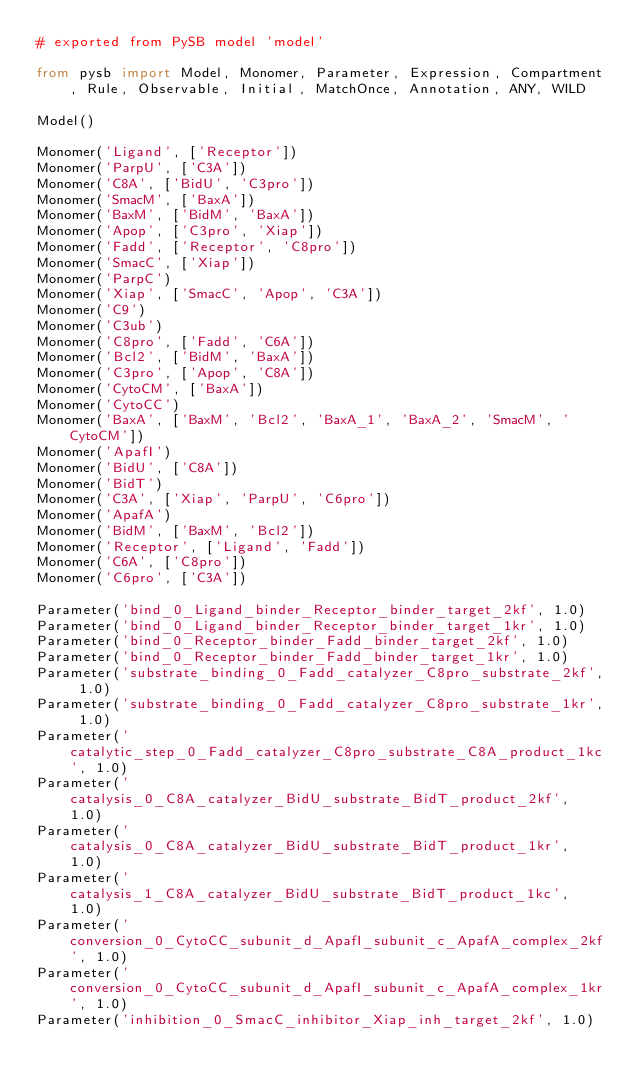<code> <loc_0><loc_0><loc_500><loc_500><_Python_># exported from PySB model 'model'

from pysb import Model, Monomer, Parameter, Expression, Compartment, Rule, Observable, Initial, MatchOnce, Annotation, ANY, WILD

Model()

Monomer('Ligand', ['Receptor'])
Monomer('ParpU', ['C3A'])
Monomer('C8A', ['BidU', 'C3pro'])
Monomer('SmacM', ['BaxA'])
Monomer('BaxM', ['BidM', 'BaxA'])
Monomer('Apop', ['C3pro', 'Xiap'])
Monomer('Fadd', ['Receptor', 'C8pro'])
Monomer('SmacC', ['Xiap'])
Monomer('ParpC')
Monomer('Xiap', ['SmacC', 'Apop', 'C3A'])
Monomer('C9')
Monomer('C3ub')
Monomer('C8pro', ['Fadd', 'C6A'])
Monomer('Bcl2', ['BidM', 'BaxA'])
Monomer('C3pro', ['Apop', 'C8A'])
Monomer('CytoCM', ['BaxA'])
Monomer('CytoCC')
Monomer('BaxA', ['BaxM', 'Bcl2', 'BaxA_1', 'BaxA_2', 'SmacM', 'CytoCM'])
Monomer('ApafI')
Monomer('BidU', ['C8A'])
Monomer('BidT')
Monomer('C3A', ['Xiap', 'ParpU', 'C6pro'])
Monomer('ApafA')
Monomer('BidM', ['BaxM', 'Bcl2'])
Monomer('Receptor', ['Ligand', 'Fadd'])
Monomer('C6A', ['C8pro'])
Monomer('C6pro', ['C3A'])

Parameter('bind_0_Ligand_binder_Receptor_binder_target_2kf', 1.0)
Parameter('bind_0_Ligand_binder_Receptor_binder_target_1kr', 1.0)
Parameter('bind_0_Receptor_binder_Fadd_binder_target_2kf', 1.0)
Parameter('bind_0_Receptor_binder_Fadd_binder_target_1kr', 1.0)
Parameter('substrate_binding_0_Fadd_catalyzer_C8pro_substrate_2kf', 1.0)
Parameter('substrate_binding_0_Fadd_catalyzer_C8pro_substrate_1kr', 1.0)
Parameter('catalytic_step_0_Fadd_catalyzer_C8pro_substrate_C8A_product_1kc', 1.0)
Parameter('catalysis_0_C8A_catalyzer_BidU_substrate_BidT_product_2kf', 1.0)
Parameter('catalysis_0_C8A_catalyzer_BidU_substrate_BidT_product_1kr', 1.0)
Parameter('catalysis_1_C8A_catalyzer_BidU_substrate_BidT_product_1kc', 1.0)
Parameter('conversion_0_CytoCC_subunit_d_ApafI_subunit_c_ApafA_complex_2kf', 1.0)
Parameter('conversion_0_CytoCC_subunit_d_ApafI_subunit_c_ApafA_complex_1kr', 1.0)
Parameter('inhibition_0_SmacC_inhibitor_Xiap_inh_target_2kf', 1.0)</code> 